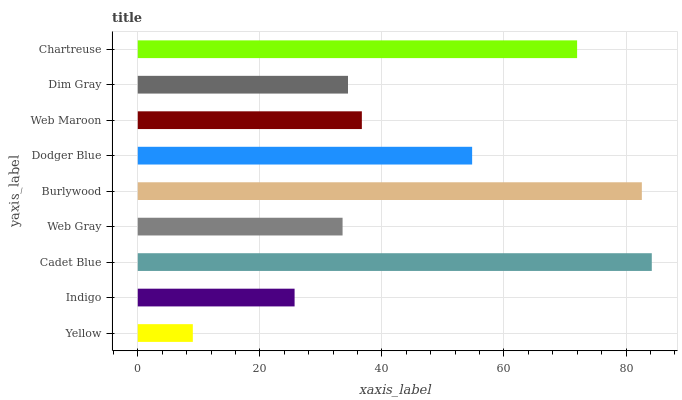Is Yellow the minimum?
Answer yes or no. Yes. Is Cadet Blue the maximum?
Answer yes or no. Yes. Is Indigo the minimum?
Answer yes or no. No. Is Indigo the maximum?
Answer yes or no. No. Is Indigo greater than Yellow?
Answer yes or no. Yes. Is Yellow less than Indigo?
Answer yes or no. Yes. Is Yellow greater than Indigo?
Answer yes or no. No. Is Indigo less than Yellow?
Answer yes or no. No. Is Web Maroon the high median?
Answer yes or no. Yes. Is Web Maroon the low median?
Answer yes or no. Yes. Is Dim Gray the high median?
Answer yes or no. No. Is Burlywood the low median?
Answer yes or no. No. 